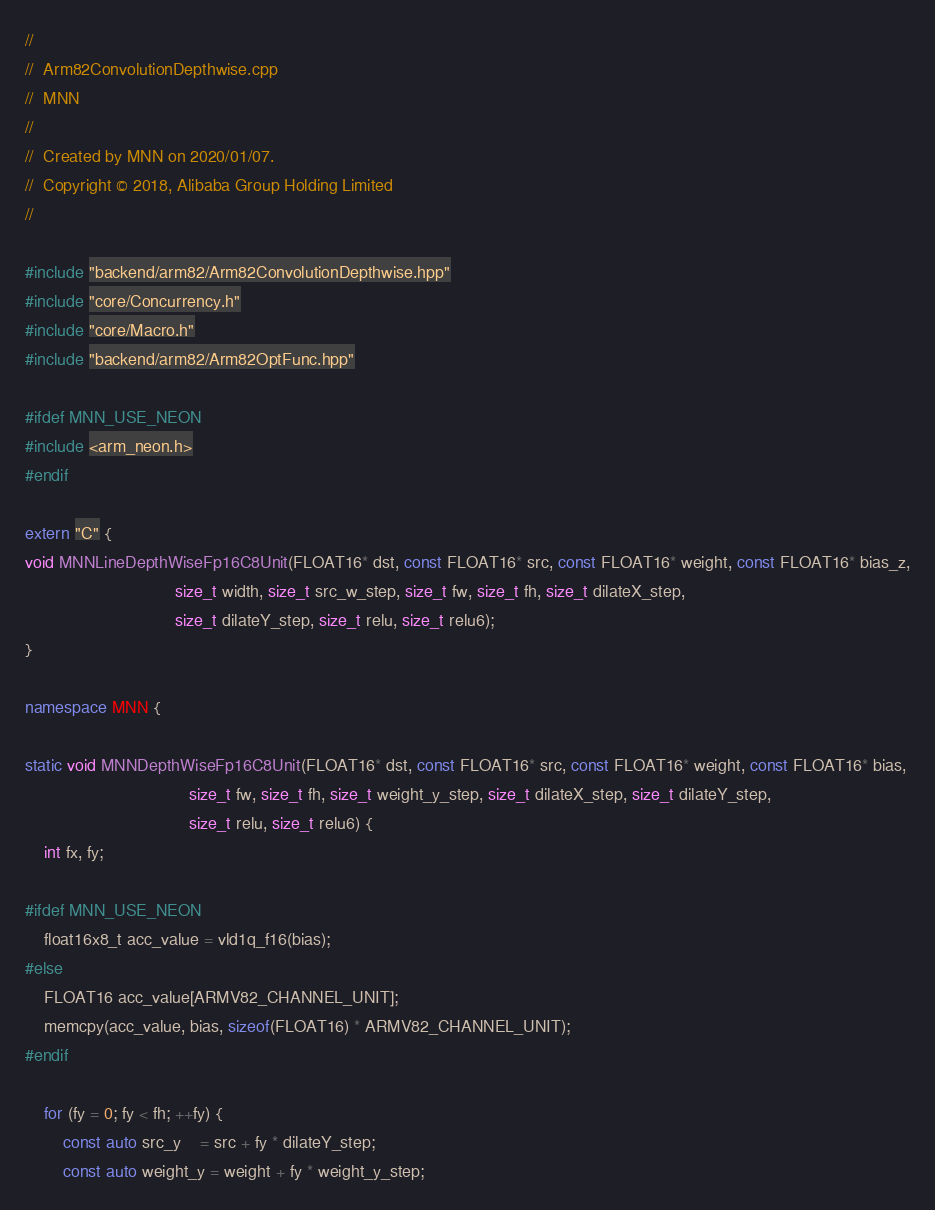<code> <loc_0><loc_0><loc_500><loc_500><_C++_>//
//  Arm82ConvolutionDepthwise.cpp
//  MNN
//
//  Created by MNN on 2020/01/07.
//  Copyright © 2018, Alibaba Group Holding Limited
//

#include "backend/arm82/Arm82ConvolutionDepthwise.hpp"
#include "core/Concurrency.h"
#include "core/Macro.h"
#include "backend/arm82/Arm82OptFunc.hpp"

#ifdef MNN_USE_NEON
#include <arm_neon.h>
#endif

extern "C" {
void MNNLineDepthWiseFp16C8Unit(FLOAT16* dst, const FLOAT16* src, const FLOAT16* weight, const FLOAT16* bias_z,
                                size_t width, size_t src_w_step, size_t fw, size_t fh, size_t dilateX_step,
                                size_t dilateY_step, size_t relu, size_t relu6);
}

namespace MNN {

static void MNNDepthWiseFp16C8Unit(FLOAT16* dst, const FLOAT16* src, const FLOAT16* weight, const FLOAT16* bias,
                                   size_t fw, size_t fh, size_t weight_y_step, size_t dilateX_step, size_t dilateY_step,
                                   size_t relu, size_t relu6) {
    int fx, fy;

#ifdef MNN_USE_NEON
    float16x8_t acc_value = vld1q_f16(bias);
#else
    FLOAT16 acc_value[ARMV82_CHANNEL_UNIT];
    memcpy(acc_value, bias, sizeof(FLOAT16) * ARMV82_CHANNEL_UNIT);
#endif

    for (fy = 0; fy < fh; ++fy) {
        const auto src_y    = src + fy * dilateY_step;
        const auto weight_y = weight + fy * weight_y_step;</code> 